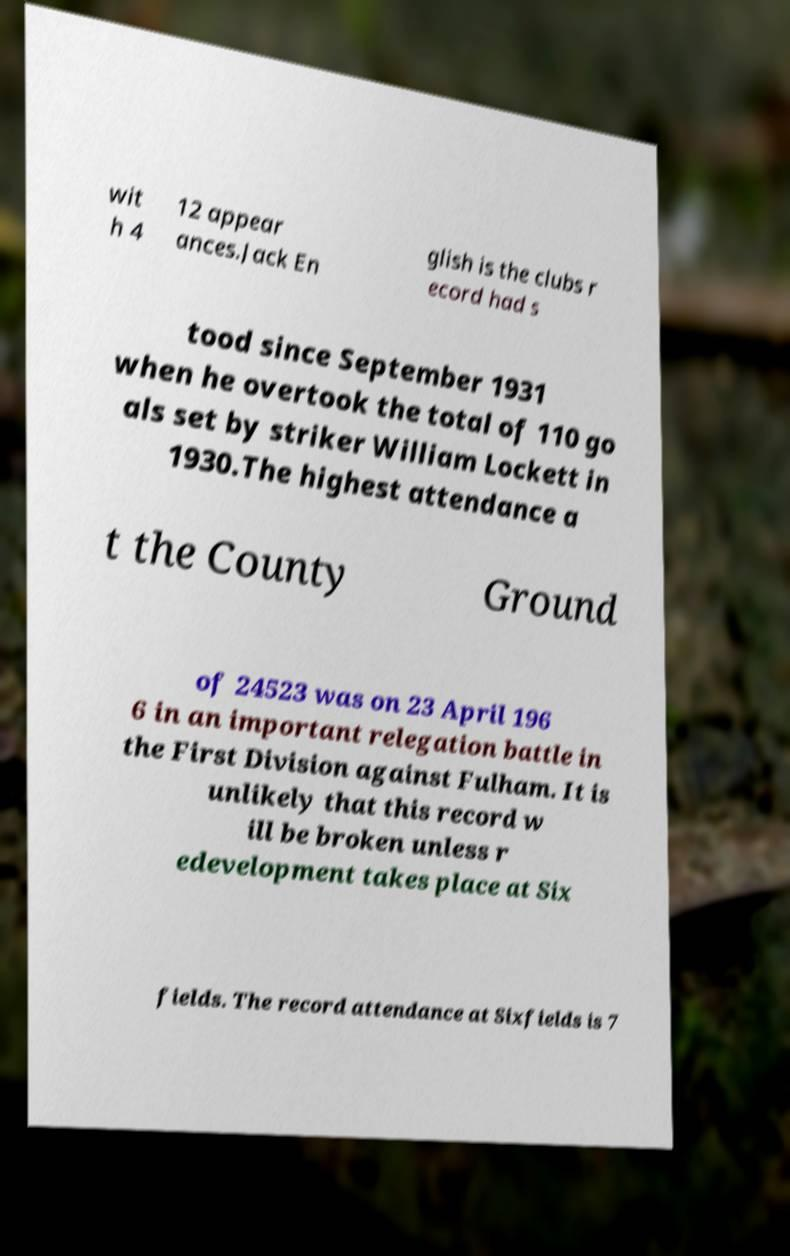Could you assist in decoding the text presented in this image and type it out clearly? wit h 4 12 appear ances.Jack En glish is the clubs r ecord had s tood since September 1931 when he overtook the total of 110 go als set by striker William Lockett in 1930.The highest attendance a t the County Ground of 24523 was on 23 April 196 6 in an important relegation battle in the First Division against Fulham. It is unlikely that this record w ill be broken unless r edevelopment takes place at Six fields. The record attendance at Sixfields is 7 